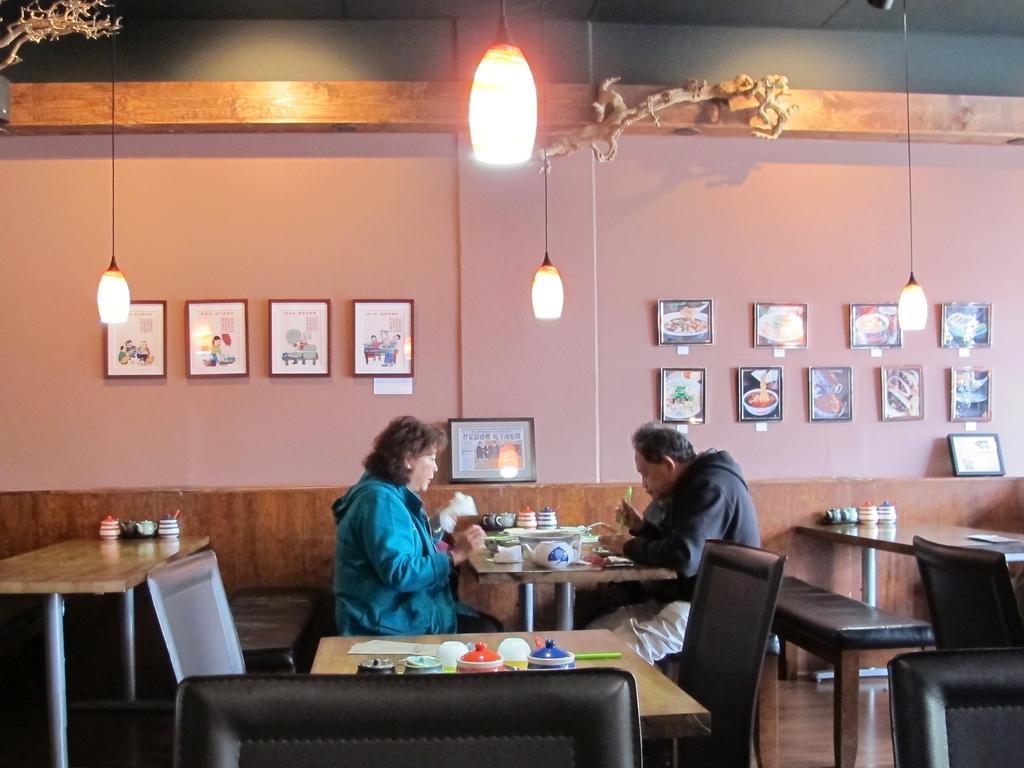Can you describe this image briefly? This is an inside view. In this image I can see a woman and a man sitting on the bench beside the table. On the table I can see few cups and bowls. In the background there is a wall, also I can see few frames are attached to this wall. On the top of the image there are some lights. 